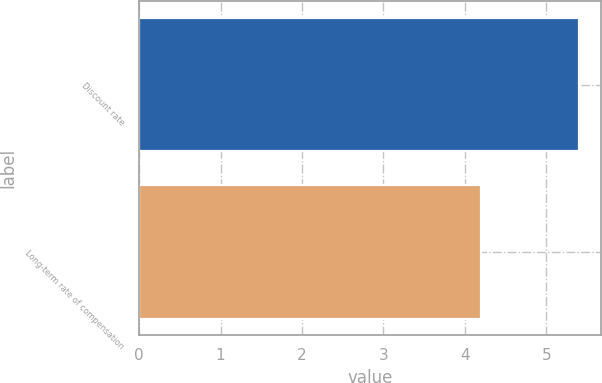Convert chart to OTSL. <chart><loc_0><loc_0><loc_500><loc_500><bar_chart><fcel>Discount rate<fcel>Long-term rate of compensation<nl><fcel>5.4<fcel>4.2<nl></chart> 